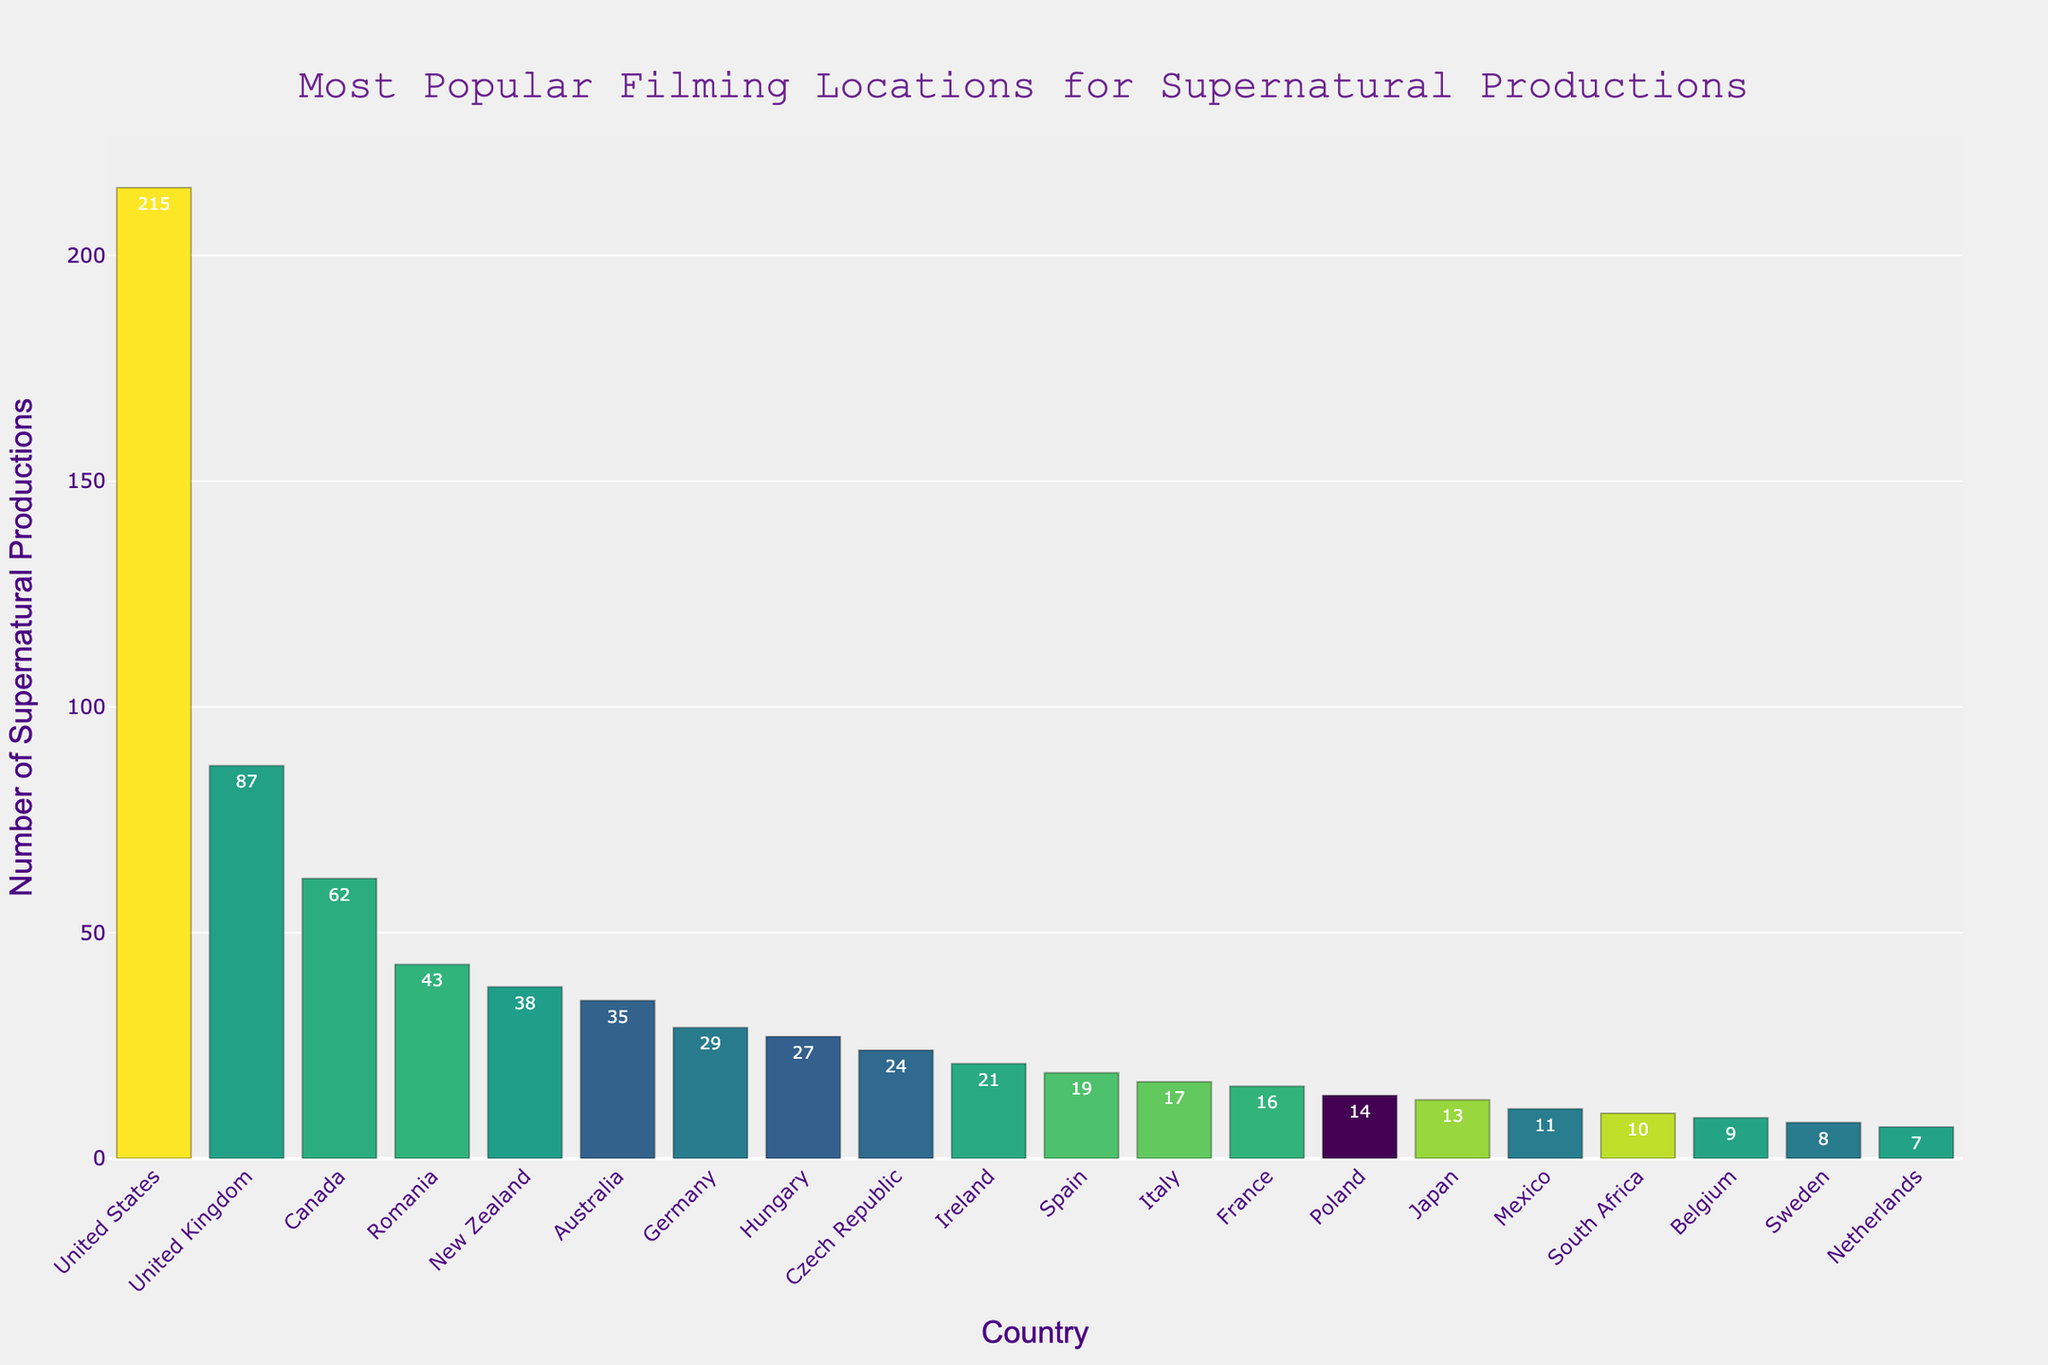Which country has the highest number of supernatural productions? Look at the bar representing the "United States"; it has the tallest bar and the highest numerical annotation.
Answer: United States Which country has fewer supernatural productions, Germany or Australia? Compare the heights of the bars and the annotations for Germany (29) and Australia (35); the Germany bar is shorter and has a lower number.
Answer: Germany How many supernatural productions are filmed in Canada and Romania combined? Sum the values for Canada (62) and Romania (43); the total is 62 + 43.
Answer: 105 What is the difference in the number of supernatural productions between the United States and the United Kingdom? Subtract the value for the United Kingdom (87) from the value for the United States (215); the result is 215 - 87.
Answer: 128 Which countries have more than 50 supernatural productions? Check the bars that exceed the 50 mark: United States (215), United Kingdom (87), and Canada (62).
Answer: United States, United Kingdom, Canada How many countries have 20 or more supernatural productions but fewer than 50? Identify bars between 20 and 50: Romania (43), New Zealand (38), Australia (35), Germany (29), Hungary (27), Czech Republic (24), Ireland (21). Count these bars.
Answer: 7 Which country has exactly 17 supernatural productions? Look for the bar with the annotation "17"; this corresponds to Italy.
Answer: Italy Do more supernatural productions occur in France or Japan? Compare the heights and numerical annotations for France (16) and Japan (13); France has a taller bar and higher number.
Answer: France What is the total number of supernatural productions in the top 3 countries combined? Sum the values for the top 3 countries: United States (215), United Kingdom (87), and Canada (62); the total is 215 + 87 + 62.
Answer: 364 What is the average number of supernatural productions among the top 5 countries? First, add up the values for the top 5 countries: United States (215), United Kingdom (87), Canada (62), Romania (43), New Zealand (38); the total is 215 + 87 + 62 + 43 + 38 = 445. Divide by 5 to get the average: 445 / 5.
Answer: 89 